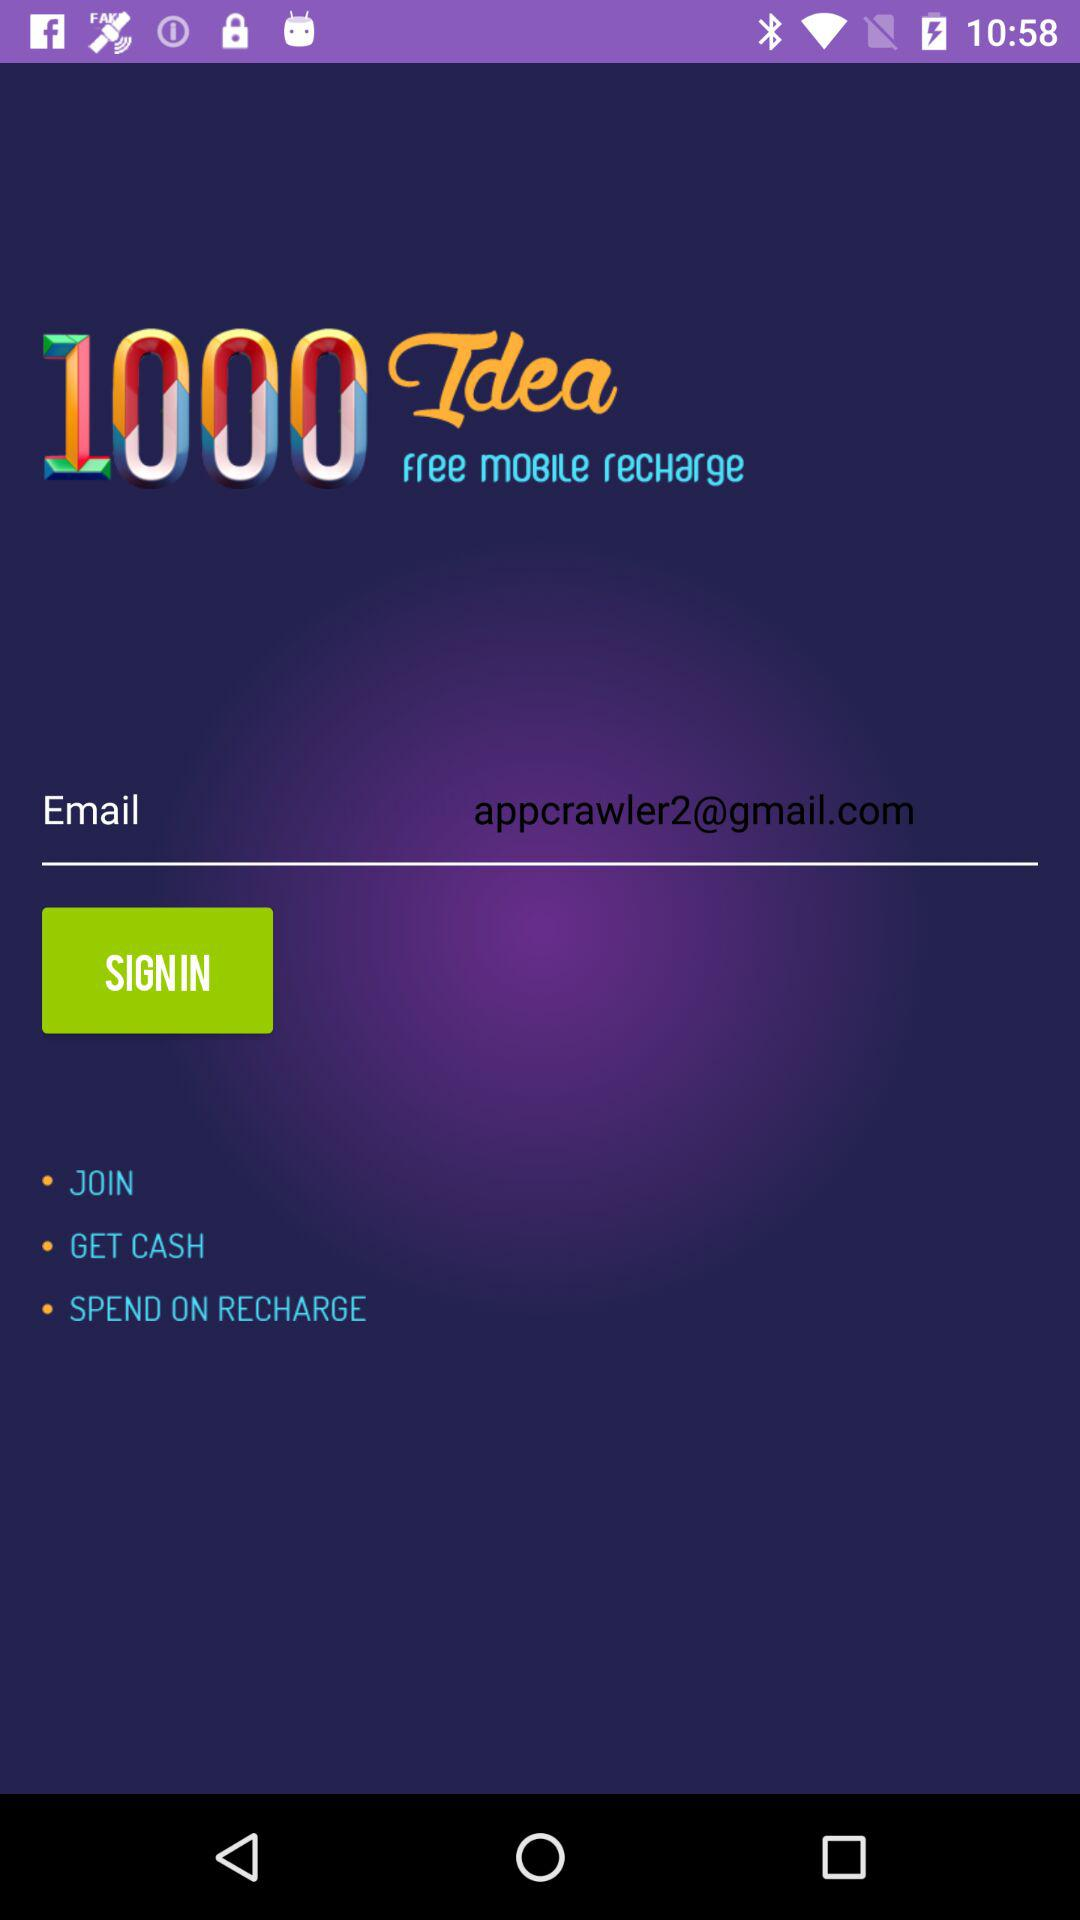What is the email address? The email address is appcrawler2@gmail.com. 